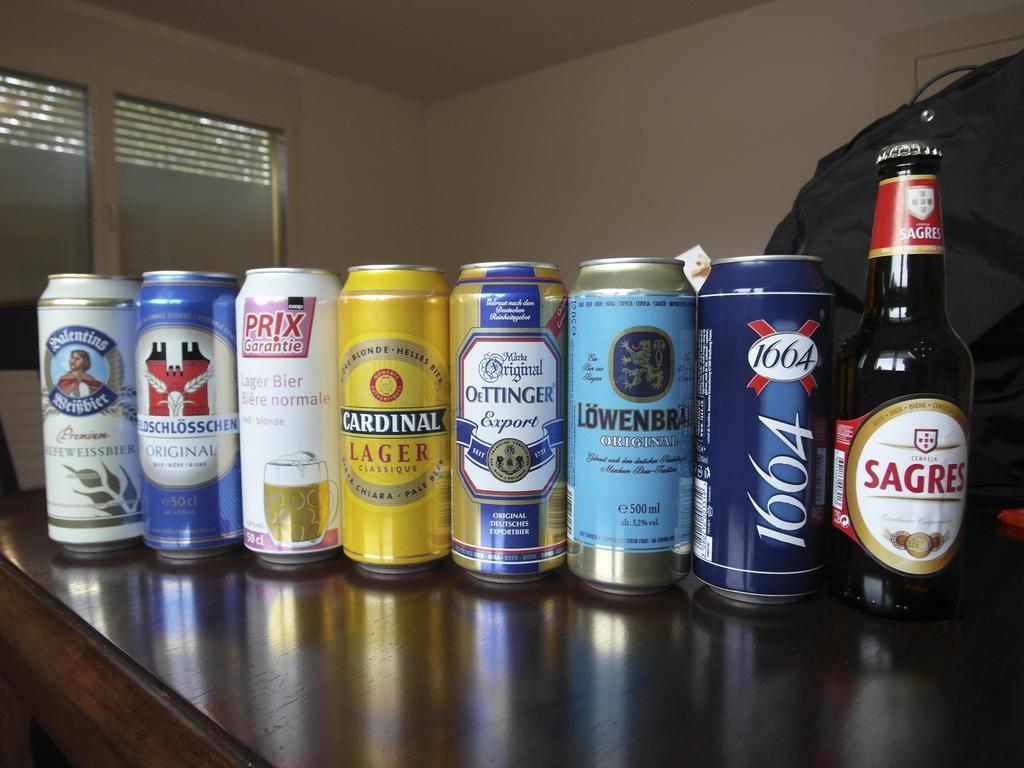Is this person a avid drinker?
Keep it short and to the point. Yes. What is the brand of alcohol on the far right?
Offer a very short reply. Sagres. 